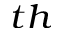Convert formula to latex. <formula><loc_0><loc_0><loc_500><loc_500>^ { t h }</formula> 